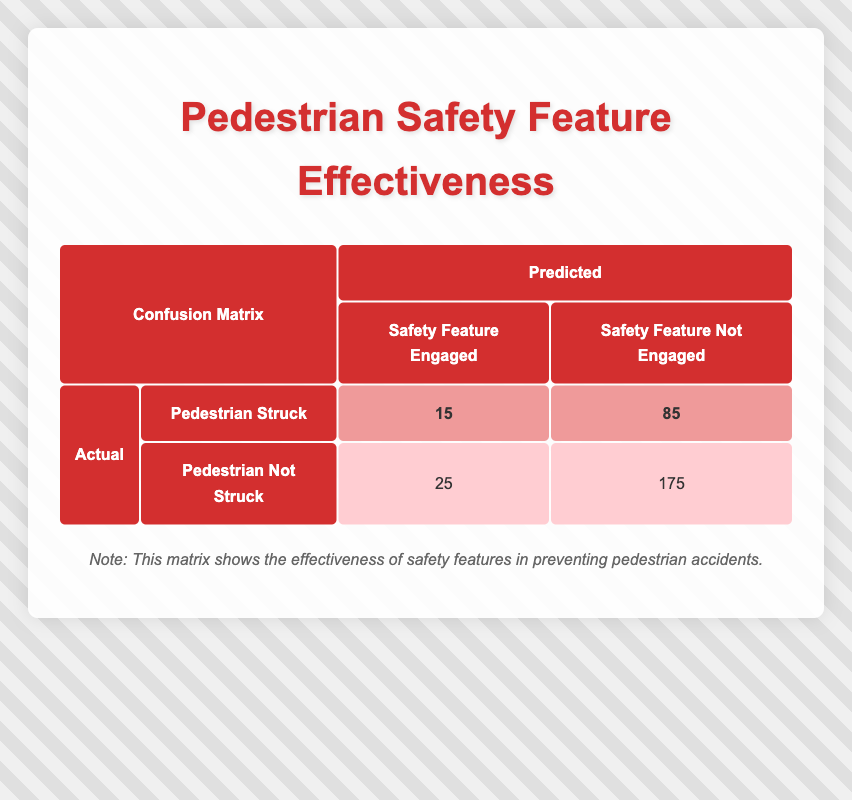What is the total number of pedestrian accidents where the safety feature was engaged? To find this, we need to sum the counts where the safety feature was engaged. This includes the "Pedestrian Struck" case (15) and "Pedestrian Not Struck" case (25). Therefore, total engaged = 15 + 25 = 40.
Answer: 40 What is the count of pedestrian accidents where the safety feature was not engaged? We can find this by summing the counts where the safety feature was not engaged. This includes the "Pedestrian Struck" case (85) and "Pedestrian Not Struck" case (175). Therefore, total not engaged = 85 + 175 = 260.
Answer: 260 Is it true that more pedestrians were not struck when the safety feature was engaged compared to when it was not engaged? When the safety feature was engaged, 25 pedestrians were not struck. When it was not engaged, 175 pedestrians were not struck. Since 25 is less than 175, the statement is false.
Answer: No What is the difference in the number of pedestrians struck when the safety feature was engaged versus not engaged? The difference can be calculated by subtracting the count of pedestrians struck with the safety feature engaged (15) from those not engaged (85). Therefore, the difference = 85 - 15 = 70.
Answer: 70 What percentage of pedestrian accidents were classified as "Pedestrian Struck" when the safety feature was not engaged? To calculate this percentage, we first find the total pedestrian accidents when the safety feature was not engaged: 85 ("Struck") + 175 ("Not Struck") = 260. The formula for percentage is (part/whole) * 100. So the percentage of "Struck" when not engaged = (85/260) * 100 ≈ 32.69%.
Answer: 32.69% 